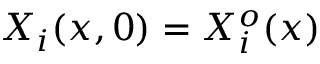<formula> <loc_0><loc_0><loc_500><loc_500>X _ { i } ( x , 0 ) = X _ { i } ^ { o } ( x )</formula> 